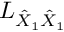<formula> <loc_0><loc_0><loc_500><loc_500>L _ { \hat { X } _ { 1 } \hat { X } _ { 1 } }</formula> 